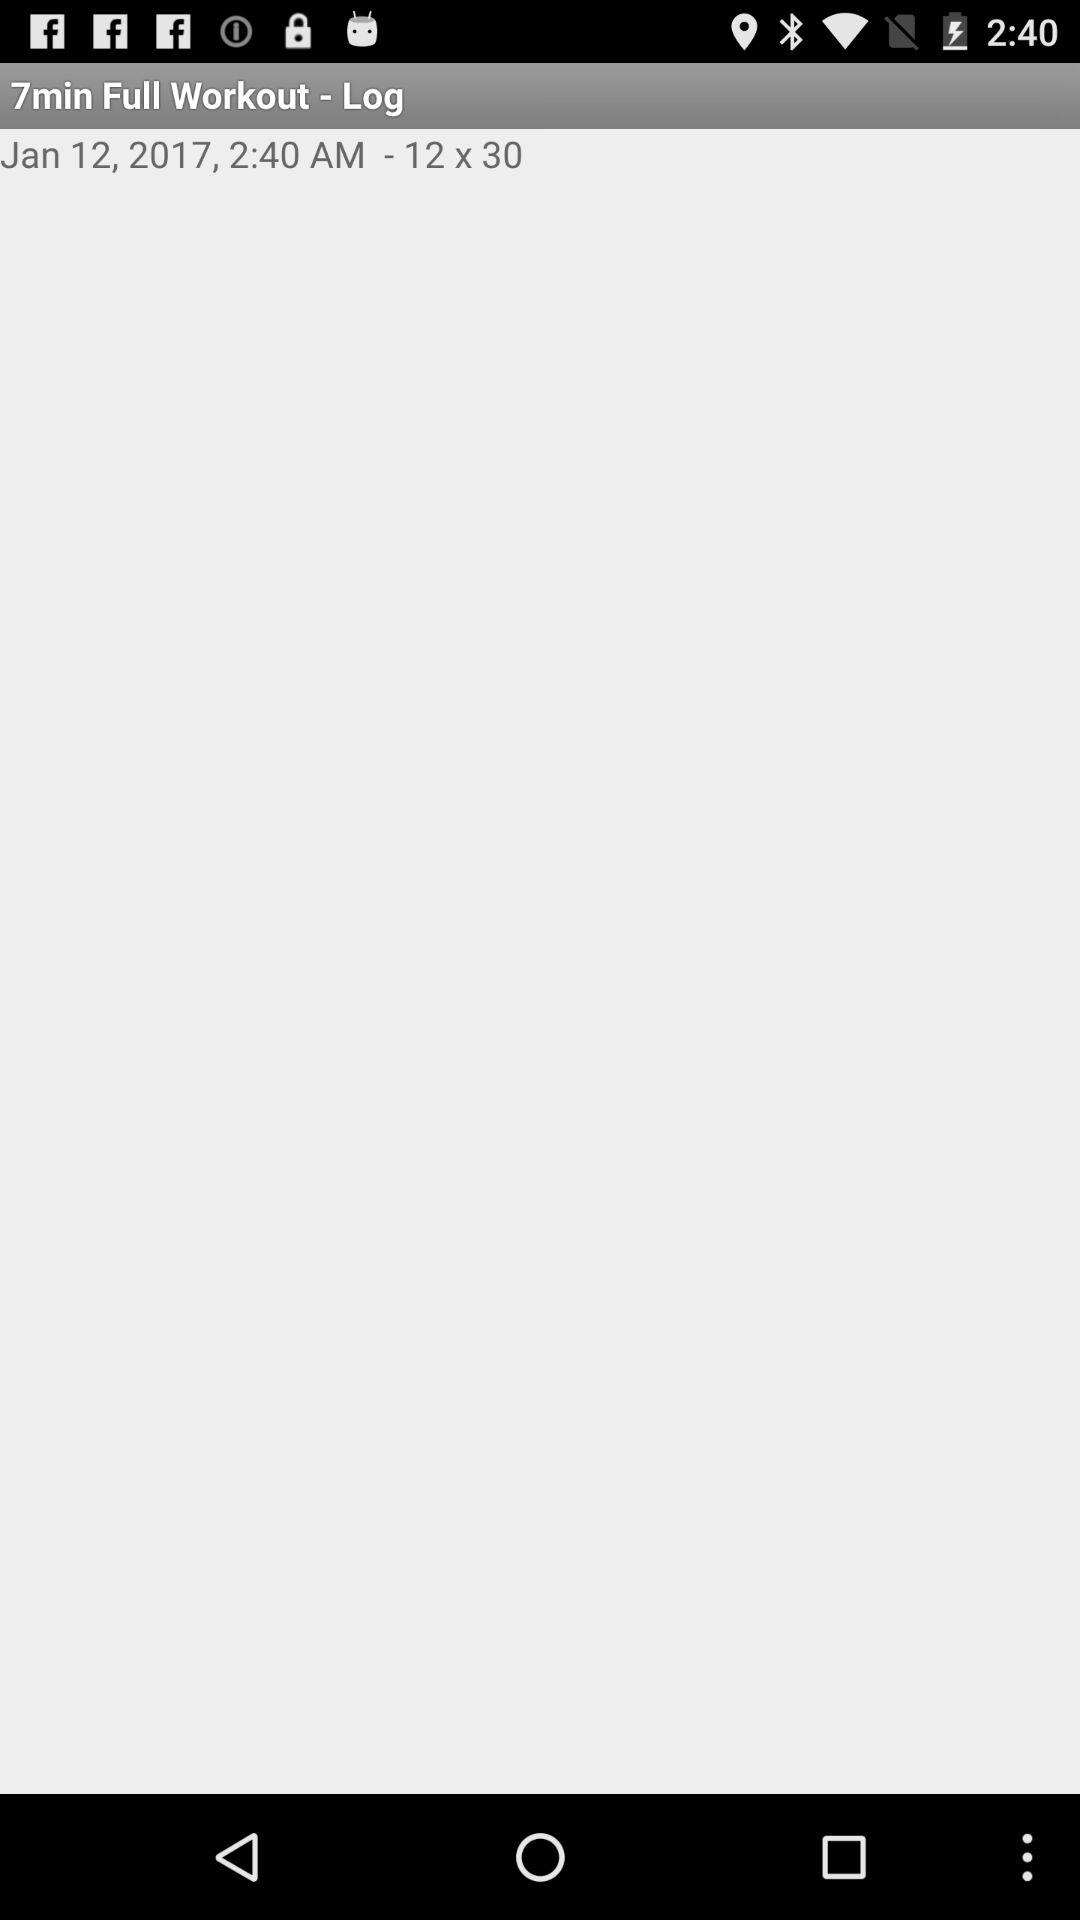What is the duration of the full workout? The duration of the full workout is 7 minutes. 